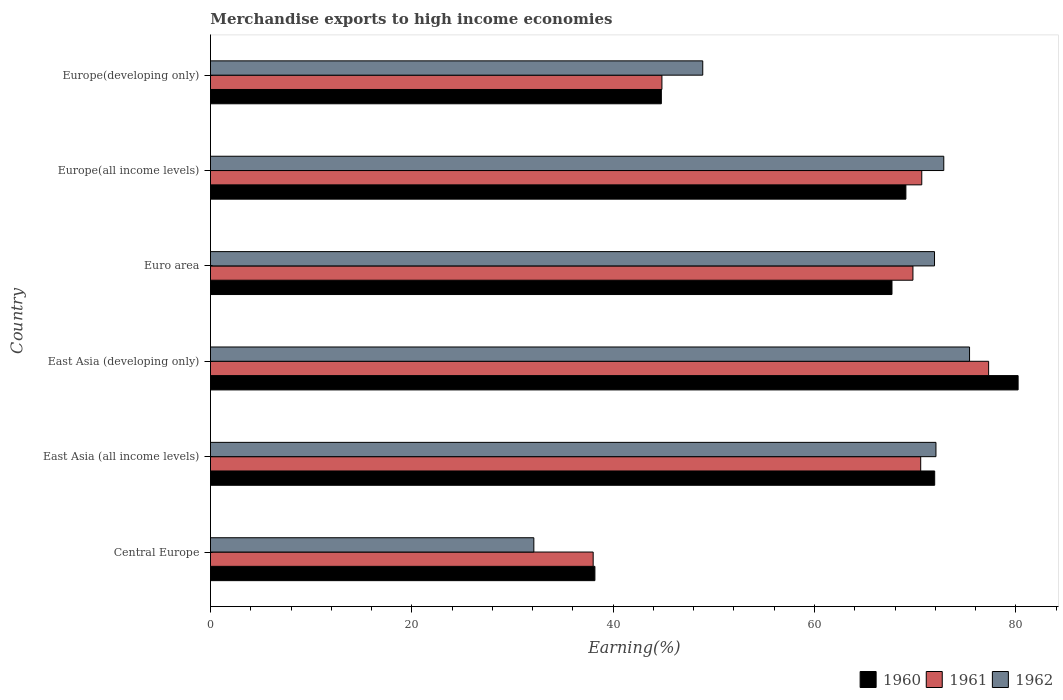How many groups of bars are there?
Offer a very short reply. 6. Are the number of bars per tick equal to the number of legend labels?
Your response must be concise. Yes. How many bars are there on the 4th tick from the bottom?
Your answer should be compact. 3. What is the label of the 1st group of bars from the top?
Provide a succinct answer. Europe(developing only). What is the percentage of amount earned from merchandise exports in 1961 in Euro area?
Provide a succinct answer. 69.78. Across all countries, what is the maximum percentage of amount earned from merchandise exports in 1962?
Ensure brevity in your answer.  75.4. Across all countries, what is the minimum percentage of amount earned from merchandise exports in 1960?
Offer a terse response. 38.19. In which country was the percentage of amount earned from merchandise exports in 1961 maximum?
Ensure brevity in your answer.  East Asia (developing only). In which country was the percentage of amount earned from merchandise exports in 1962 minimum?
Give a very brief answer. Central Europe. What is the total percentage of amount earned from merchandise exports in 1961 in the graph?
Your answer should be compact. 371.15. What is the difference between the percentage of amount earned from merchandise exports in 1962 in Central Europe and that in Euro area?
Provide a succinct answer. -39.8. What is the difference between the percentage of amount earned from merchandise exports in 1962 in Europe(all income levels) and the percentage of amount earned from merchandise exports in 1961 in East Asia (developing only)?
Provide a succinct answer. -4.45. What is the average percentage of amount earned from merchandise exports in 1962 per country?
Ensure brevity in your answer.  62.21. What is the difference between the percentage of amount earned from merchandise exports in 1962 and percentage of amount earned from merchandise exports in 1961 in Euro area?
Offer a terse response. 2.14. In how many countries, is the percentage of amount earned from merchandise exports in 1961 greater than 4 %?
Keep it short and to the point. 6. What is the ratio of the percentage of amount earned from merchandise exports in 1962 in East Asia (developing only) to that in Euro area?
Offer a very short reply. 1.05. What is the difference between the highest and the second highest percentage of amount earned from merchandise exports in 1961?
Your response must be concise. 6.64. What is the difference between the highest and the lowest percentage of amount earned from merchandise exports in 1961?
Provide a succinct answer. 39.28. In how many countries, is the percentage of amount earned from merchandise exports in 1960 greater than the average percentage of amount earned from merchandise exports in 1960 taken over all countries?
Give a very brief answer. 4. Is the sum of the percentage of amount earned from merchandise exports in 1960 in Europe(all income levels) and Europe(developing only) greater than the maximum percentage of amount earned from merchandise exports in 1962 across all countries?
Your answer should be compact. Yes. What does the 3rd bar from the top in East Asia (all income levels) represents?
Your response must be concise. 1960. What does the 2nd bar from the bottom in East Asia (all income levels) represents?
Your answer should be very brief. 1961. Are all the bars in the graph horizontal?
Your response must be concise. Yes. How many countries are there in the graph?
Your answer should be compact. 6. What is the difference between two consecutive major ticks on the X-axis?
Your answer should be very brief. 20. Are the values on the major ticks of X-axis written in scientific E-notation?
Ensure brevity in your answer.  No. How are the legend labels stacked?
Offer a terse response. Horizontal. What is the title of the graph?
Give a very brief answer. Merchandise exports to high income economies. What is the label or title of the X-axis?
Provide a short and direct response. Earning(%). What is the Earning(%) in 1960 in Central Europe?
Your answer should be compact. 38.19. What is the Earning(%) of 1961 in Central Europe?
Offer a terse response. 38.02. What is the Earning(%) in 1962 in Central Europe?
Your response must be concise. 32.12. What is the Earning(%) of 1960 in East Asia (all income levels)?
Offer a very short reply. 71.94. What is the Earning(%) in 1961 in East Asia (all income levels)?
Give a very brief answer. 70.55. What is the Earning(%) of 1962 in East Asia (all income levels)?
Offer a terse response. 72.07. What is the Earning(%) in 1960 in East Asia (developing only)?
Your answer should be very brief. 80.23. What is the Earning(%) in 1961 in East Asia (developing only)?
Offer a very short reply. 77.3. What is the Earning(%) in 1962 in East Asia (developing only)?
Your response must be concise. 75.4. What is the Earning(%) in 1960 in Euro area?
Provide a short and direct response. 67.7. What is the Earning(%) in 1961 in Euro area?
Your answer should be very brief. 69.78. What is the Earning(%) of 1962 in Euro area?
Your response must be concise. 71.92. What is the Earning(%) of 1960 in Europe(all income levels)?
Your answer should be compact. 69.08. What is the Earning(%) in 1961 in Europe(all income levels)?
Your answer should be very brief. 70.66. What is the Earning(%) in 1962 in Europe(all income levels)?
Your answer should be very brief. 72.84. What is the Earning(%) of 1960 in Europe(developing only)?
Provide a succinct answer. 44.79. What is the Earning(%) in 1961 in Europe(developing only)?
Make the answer very short. 44.84. What is the Earning(%) of 1962 in Europe(developing only)?
Keep it short and to the point. 48.9. Across all countries, what is the maximum Earning(%) of 1960?
Keep it short and to the point. 80.23. Across all countries, what is the maximum Earning(%) in 1961?
Offer a terse response. 77.3. Across all countries, what is the maximum Earning(%) of 1962?
Give a very brief answer. 75.4. Across all countries, what is the minimum Earning(%) in 1960?
Provide a short and direct response. 38.19. Across all countries, what is the minimum Earning(%) in 1961?
Your answer should be very brief. 38.02. Across all countries, what is the minimum Earning(%) of 1962?
Provide a short and direct response. 32.12. What is the total Earning(%) of 1960 in the graph?
Ensure brevity in your answer.  371.92. What is the total Earning(%) of 1961 in the graph?
Provide a succinct answer. 371.15. What is the total Earning(%) in 1962 in the graph?
Offer a terse response. 373.26. What is the difference between the Earning(%) of 1960 in Central Europe and that in East Asia (all income levels)?
Provide a short and direct response. -33.75. What is the difference between the Earning(%) of 1961 in Central Europe and that in East Asia (all income levels)?
Provide a succinct answer. -32.54. What is the difference between the Earning(%) of 1962 in Central Europe and that in East Asia (all income levels)?
Your answer should be very brief. -39.94. What is the difference between the Earning(%) of 1960 in Central Europe and that in East Asia (developing only)?
Make the answer very short. -42.04. What is the difference between the Earning(%) of 1961 in Central Europe and that in East Asia (developing only)?
Ensure brevity in your answer.  -39.28. What is the difference between the Earning(%) in 1962 in Central Europe and that in East Asia (developing only)?
Provide a short and direct response. -43.28. What is the difference between the Earning(%) of 1960 in Central Europe and that in Euro area?
Your response must be concise. -29.51. What is the difference between the Earning(%) of 1961 in Central Europe and that in Euro area?
Ensure brevity in your answer.  -31.76. What is the difference between the Earning(%) of 1962 in Central Europe and that in Euro area?
Ensure brevity in your answer.  -39.8. What is the difference between the Earning(%) in 1960 in Central Europe and that in Europe(all income levels)?
Ensure brevity in your answer.  -30.89. What is the difference between the Earning(%) of 1961 in Central Europe and that in Europe(all income levels)?
Provide a short and direct response. -32.64. What is the difference between the Earning(%) in 1962 in Central Europe and that in Europe(all income levels)?
Your answer should be very brief. -40.72. What is the difference between the Earning(%) of 1960 in Central Europe and that in Europe(developing only)?
Offer a very short reply. -6.6. What is the difference between the Earning(%) in 1961 in Central Europe and that in Europe(developing only)?
Your answer should be compact. -6.83. What is the difference between the Earning(%) in 1962 in Central Europe and that in Europe(developing only)?
Ensure brevity in your answer.  -16.78. What is the difference between the Earning(%) of 1960 in East Asia (all income levels) and that in East Asia (developing only)?
Make the answer very short. -8.29. What is the difference between the Earning(%) of 1961 in East Asia (all income levels) and that in East Asia (developing only)?
Provide a succinct answer. -6.75. What is the difference between the Earning(%) in 1962 in East Asia (all income levels) and that in East Asia (developing only)?
Give a very brief answer. -3.34. What is the difference between the Earning(%) of 1960 in East Asia (all income levels) and that in Euro area?
Keep it short and to the point. 4.24. What is the difference between the Earning(%) of 1961 in East Asia (all income levels) and that in Euro area?
Keep it short and to the point. 0.77. What is the difference between the Earning(%) of 1962 in East Asia (all income levels) and that in Euro area?
Offer a terse response. 0.14. What is the difference between the Earning(%) in 1960 in East Asia (all income levels) and that in Europe(all income levels)?
Give a very brief answer. 2.86. What is the difference between the Earning(%) of 1961 in East Asia (all income levels) and that in Europe(all income levels)?
Make the answer very short. -0.1. What is the difference between the Earning(%) of 1962 in East Asia (all income levels) and that in Europe(all income levels)?
Ensure brevity in your answer.  -0.78. What is the difference between the Earning(%) of 1960 in East Asia (all income levels) and that in Europe(developing only)?
Your response must be concise. 27.15. What is the difference between the Earning(%) in 1961 in East Asia (all income levels) and that in Europe(developing only)?
Your answer should be very brief. 25.71. What is the difference between the Earning(%) of 1962 in East Asia (all income levels) and that in Europe(developing only)?
Your answer should be compact. 23.17. What is the difference between the Earning(%) of 1960 in East Asia (developing only) and that in Euro area?
Make the answer very short. 12.53. What is the difference between the Earning(%) in 1961 in East Asia (developing only) and that in Euro area?
Give a very brief answer. 7.52. What is the difference between the Earning(%) in 1962 in East Asia (developing only) and that in Euro area?
Your answer should be very brief. 3.48. What is the difference between the Earning(%) in 1960 in East Asia (developing only) and that in Europe(all income levels)?
Keep it short and to the point. 11.15. What is the difference between the Earning(%) of 1961 in East Asia (developing only) and that in Europe(all income levels)?
Give a very brief answer. 6.64. What is the difference between the Earning(%) in 1962 in East Asia (developing only) and that in Europe(all income levels)?
Provide a succinct answer. 2.56. What is the difference between the Earning(%) of 1960 in East Asia (developing only) and that in Europe(developing only)?
Provide a short and direct response. 35.44. What is the difference between the Earning(%) in 1961 in East Asia (developing only) and that in Europe(developing only)?
Provide a succinct answer. 32.45. What is the difference between the Earning(%) in 1962 in East Asia (developing only) and that in Europe(developing only)?
Your answer should be compact. 26.5. What is the difference between the Earning(%) in 1960 in Euro area and that in Europe(all income levels)?
Ensure brevity in your answer.  -1.38. What is the difference between the Earning(%) in 1961 in Euro area and that in Europe(all income levels)?
Your answer should be compact. -0.88. What is the difference between the Earning(%) of 1962 in Euro area and that in Europe(all income levels)?
Provide a succinct answer. -0.92. What is the difference between the Earning(%) in 1960 in Euro area and that in Europe(developing only)?
Your answer should be compact. 22.91. What is the difference between the Earning(%) in 1961 in Euro area and that in Europe(developing only)?
Your answer should be very brief. 24.93. What is the difference between the Earning(%) in 1962 in Euro area and that in Europe(developing only)?
Your answer should be compact. 23.02. What is the difference between the Earning(%) of 1960 in Europe(all income levels) and that in Europe(developing only)?
Give a very brief answer. 24.29. What is the difference between the Earning(%) of 1961 in Europe(all income levels) and that in Europe(developing only)?
Your response must be concise. 25.81. What is the difference between the Earning(%) in 1962 in Europe(all income levels) and that in Europe(developing only)?
Your response must be concise. 23.94. What is the difference between the Earning(%) of 1960 in Central Europe and the Earning(%) of 1961 in East Asia (all income levels)?
Provide a short and direct response. -32.36. What is the difference between the Earning(%) of 1960 in Central Europe and the Earning(%) of 1962 in East Asia (all income levels)?
Give a very brief answer. -33.88. What is the difference between the Earning(%) in 1961 in Central Europe and the Earning(%) in 1962 in East Asia (all income levels)?
Provide a short and direct response. -34.05. What is the difference between the Earning(%) in 1960 in Central Europe and the Earning(%) in 1961 in East Asia (developing only)?
Offer a very short reply. -39.11. What is the difference between the Earning(%) in 1960 in Central Europe and the Earning(%) in 1962 in East Asia (developing only)?
Provide a short and direct response. -37.22. What is the difference between the Earning(%) of 1961 in Central Europe and the Earning(%) of 1962 in East Asia (developing only)?
Offer a terse response. -37.39. What is the difference between the Earning(%) of 1960 in Central Europe and the Earning(%) of 1961 in Euro area?
Your answer should be compact. -31.59. What is the difference between the Earning(%) of 1960 in Central Europe and the Earning(%) of 1962 in Euro area?
Give a very brief answer. -33.74. What is the difference between the Earning(%) in 1961 in Central Europe and the Earning(%) in 1962 in Euro area?
Provide a succinct answer. -33.91. What is the difference between the Earning(%) in 1960 in Central Europe and the Earning(%) in 1961 in Europe(all income levels)?
Provide a succinct answer. -32.47. What is the difference between the Earning(%) in 1960 in Central Europe and the Earning(%) in 1962 in Europe(all income levels)?
Ensure brevity in your answer.  -34.66. What is the difference between the Earning(%) of 1961 in Central Europe and the Earning(%) of 1962 in Europe(all income levels)?
Give a very brief answer. -34.83. What is the difference between the Earning(%) of 1960 in Central Europe and the Earning(%) of 1961 in Europe(developing only)?
Keep it short and to the point. -6.66. What is the difference between the Earning(%) of 1960 in Central Europe and the Earning(%) of 1962 in Europe(developing only)?
Offer a very short reply. -10.71. What is the difference between the Earning(%) of 1961 in Central Europe and the Earning(%) of 1962 in Europe(developing only)?
Offer a very short reply. -10.88. What is the difference between the Earning(%) of 1960 in East Asia (all income levels) and the Earning(%) of 1961 in East Asia (developing only)?
Offer a terse response. -5.36. What is the difference between the Earning(%) in 1960 in East Asia (all income levels) and the Earning(%) in 1962 in East Asia (developing only)?
Keep it short and to the point. -3.46. What is the difference between the Earning(%) in 1961 in East Asia (all income levels) and the Earning(%) in 1962 in East Asia (developing only)?
Your answer should be compact. -4.85. What is the difference between the Earning(%) in 1960 in East Asia (all income levels) and the Earning(%) in 1961 in Euro area?
Make the answer very short. 2.16. What is the difference between the Earning(%) of 1960 in East Asia (all income levels) and the Earning(%) of 1962 in Euro area?
Keep it short and to the point. 0.02. What is the difference between the Earning(%) of 1961 in East Asia (all income levels) and the Earning(%) of 1962 in Euro area?
Your answer should be very brief. -1.37. What is the difference between the Earning(%) in 1960 in East Asia (all income levels) and the Earning(%) in 1961 in Europe(all income levels)?
Your answer should be compact. 1.28. What is the difference between the Earning(%) of 1960 in East Asia (all income levels) and the Earning(%) of 1962 in Europe(all income levels)?
Your answer should be compact. -0.9. What is the difference between the Earning(%) of 1961 in East Asia (all income levels) and the Earning(%) of 1962 in Europe(all income levels)?
Give a very brief answer. -2.29. What is the difference between the Earning(%) in 1960 in East Asia (all income levels) and the Earning(%) in 1961 in Europe(developing only)?
Offer a very short reply. 27.1. What is the difference between the Earning(%) of 1960 in East Asia (all income levels) and the Earning(%) of 1962 in Europe(developing only)?
Make the answer very short. 23.04. What is the difference between the Earning(%) of 1961 in East Asia (all income levels) and the Earning(%) of 1962 in Europe(developing only)?
Give a very brief answer. 21.65. What is the difference between the Earning(%) of 1960 in East Asia (developing only) and the Earning(%) of 1961 in Euro area?
Provide a short and direct response. 10.45. What is the difference between the Earning(%) of 1960 in East Asia (developing only) and the Earning(%) of 1962 in Euro area?
Your answer should be very brief. 8.3. What is the difference between the Earning(%) of 1961 in East Asia (developing only) and the Earning(%) of 1962 in Euro area?
Your answer should be compact. 5.37. What is the difference between the Earning(%) of 1960 in East Asia (developing only) and the Earning(%) of 1961 in Europe(all income levels)?
Make the answer very short. 9.57. What is the difference between the Earning(%) in 1960 in East Asia (developing only) and the Earning(%) in 1962 in Europe(all income levels)?
Your response must be concise. 7.38. What is the difference between the Earning(%) in 1961 in East Asia (developing only) and the Earning(%) in 1962 in Europe(all income levels)?
Offer a very short reply. 4.45. What is the difference between the Earning(%) in 1960 in East Asia (developing only) and the Earning(%) in 1961 in Europe(developing only)?
Make the answer very short. 35.38. What is the difference between the Earning(%) in 1960 in East Asia (developing only) and the Earning(%) in 1962 in Europe(developing only)?
Your answer should be very brief. 31.33. What is the difference between the Earning(%) of 1961 in East Asia (developing only) and the Earning(%) of 1962 in Europe(developing only)?
Make the answer very short. 28.4. What is the difference between the Earning(%) in 1960 in Euro area and the Earning(%) in 1961 in Europe(all income levels)?
Make the answer very short. -2.96. What is the difference between the Earning(%) of 1960 in Euro area and the Earning(%) of 1962 in Europe(all income levels)?
Provide a succinct answer. -5.15. What is the difference between the Earning(%) of 1961 in Euro area and the Earning(%) of 1962 in Europe(all income levels)?
Give a very brief answer. -3.06. What is the difference between the Earning(%) of 1960 in Euro area and the Earning(%) of 1961 in Europe(developing only)?
Ensure brevity in your answer.  22.85. What is the difference between the Earning(%) of 1960 in Euro area and the Earning(%) of 1962 in Europe(developing only)?
Provide a succinct answer. 18.8. What is the difference between the Earning(%) of 1961 in Euro area and the Earning(%) of 1962 in Europe(developing only)?
Offer a very short reply. 20.88. What is the difference between the Earning(%) in 1960 in Europe(all income levels) and the Earning(%) in 1961 in Europe(developing only)?
Keep it short and to the point. 24.24. What is the difference between the Earning(%) of 1960 in Europe(all income levels) and the Earning(%) of 1962 in Europe(developing only)?
Give a very brief answer. 20.18. What is the difference between the Earning(%) of 1961 in Europe(all income levels) and the Earning(%) of 1962 in Europe(developing only)?
Provide a succinct answer. 21.76. What is the average Earning(%) of 1960 per country?
Give a very brief answer. 61.99. What is the average Earning(%) in 1961 per country?
Your answer should be compact. 61.86. What is the average Earning(%) of 1962 per country?
Provide a succinct answer. 62.21. What is the difference between the Earning(%) of 1960 and Earning(%) of 1961 in Central Europe?
Offer a very short reply. 0.17. What is the difference between the Earning(%) of 1960 and Earning(%) of 1962 in Central Europe?
Offer a terse response. 6.07. What is the difference between the Earning(%) of 1961 and Earning(%) of 1962 in Central Europe?
Provide a short and direct response. 5.89. What is the difference between the Earning(%) of 1960 and Earning(%) of 1961 in East Asia (all income levels)?
Provide a succinct answer. 1.39. What is the difference between the Earning(%) in 1960 and Earning(%) in 1962 in East Asia (all income levels)?
Ensure brevity in your answer.  -0.13. What is the difference between the Earning(%) of 1961 and Earning(%) of 1962 in East Asia (all income levels)?
Your answer should be compact. -1.51. What is the difference between the Earning(%) in 1960 and Earning(%) in 1961 in East Asia (developing only)?
Your answer should be very brief. 2.93. What is the difference between the Earning(%) of 1960 and Earning(%) of 1962 in East Asia (developing only)?
Offer a terse response. 4.82. What is the difference between the Earning(%) of 1961 and Earning(%) of 1962 in East Asia (developing only)?
Offer a terse response. 1.89. What is the difference between the Earning(%) of 1960 and Earning(%) of 1961 in Euro area?
Provide a succinct answer. -2.08. What is the difference between the Earning(%) of 1960 and Earning(%) of 1962 in Euro area?
Your answer should be very brief. -4.23. What is the difference between the Earning(%) of 1961 and Earning(%) of 1962 in Euro area?
Offer a very short reply. -2.14. What is the difference between the Earning(%) of 1960 and Earning(%) of 1961 in Europe(all income levels)?
Keep it short and to the point. -1.58. What is the difference between the Earning(%) of 1960 and Earning(%) of 1962 in Europe(all income levels)?
Your answer should be compact. -3.76. What is the difference between the Earning(%) in 1961 and Earning(%) in 1962 in Europe(all income levels)?
Keep it short and to the point. -2.19. What is the difference between the Earning(%) in 1960 and Earning(%) in 1961 in Europe(developing only)?
Keep it short and to the point. -0.06. What is the difference between the Earning(%) in 1960 and Earning(%) in 1962 in Europe(developing only)?
Keep it short and to the point. -4.11. What is the difference between the Earning(%) in 1961 and Earning(%) in 1962 in Europe(developing only)?
Your response must be concise. -4.06. What is the ratio of the Earning(%) in 1960 in Central Europe to that in East Asia (all income levels)?
Give a very brief answer. 0.53. What is the ratio of the Earning(%) in 1961 in Central Europe to that in East Asia (all income levels)?
Your response must be concise. 0.54. What is the ratio of the Earning(%) in 1962 in Central Europe to that in East Asia (all income levels)?
Keep it short and to the point. 0.45. What is the ratio of the Earning(%) in 1960 in Central Europe to that in East Asia (developing only)?
Offer a very short reply. 0.48. What is the ratio of the Earning(%) in 1961 in Central Europe to that in East Asia (developing only)?
Offer a terse response. 0.49. What is the ratio of the Earning(%) of 1962 in Central Europe to that in East Asia (developing only)?
Keep it short and to the point. 0.43. What is the ratio of the Earning(%) in 1960 in Central Europe to that in Euro area?
Your response must be concise. 0.56. What is the ratio of the Earning(%) in 1961 in Central Europe to that in Euro area?
Offer a terse response. 0.54. What is the ratio of the Earning(%) of 1962 in Central Europe to that in Euro area?
Your answer should be compact. 0.45. What is the ratio of the Earning(%) of 1960 in Central Europe to that in Europe(all income levels)?
Ensure brevity in your answer.  0.55. What is the ratio of the Earning(%) of 1961 in Central Europe to that in Europe(all income levels)?
Offer a very short reply. 0.54. What is the ratio of the Earning(%) in 1962 in Central Europe to that in Europe(all income levels)?
Ensure brevity in your answer.  0.44. What is the ratio of the Earning(%) of 1960 in Central Europe to that in Europe(developing only)?
Ensure brevity in your answer.  0.85. What is the ratio of the Earning(%) in 1961 in Central Europe to that in Europe(developing only)?
Keep it short and to the point. 0.85. What is the ratio of the Earning(%) of 1962 in Central Europe to that in Europe(developing only)?
Your answer should be compact. 0.66. What is the ratio of the Earning(%) of 1960 in East Asia (all income levels) to that in East Asia (developing only)?
Make the answer very short. 0.9. What is the ratio of the Earning(%) of 1961 in East Asia (all income levels) to that in East Asia (developing only)?
Give a very brief answer. 0.91. What is the ratio of the Earning(%) in 1962 in East Asia (all income levels) to that in East Asia (developing only)?
Give a very brief answer. 0.96. What is the ratio of the Earning(%) of 1960 in East Asia (all income levels) to that in Euro area?
Provide a short and direct response. 1.06. What is the ratio of the Earning(%) in 1961 in East Asia (all income levels) to that in Euro area?
Your answer should be very brief. 1.01. What is the ratio of the Earning(%) in 1962 in East Asia (all income levels) to that in Euro area?
Offer a very short reply. 1. What is the ratio of the Earning(%) in 1960 in East Asia (all income levels) to that in Europe(all income levels)?
Make the answer very short. 1.04. What is the ratio of the Earning(%) in 1962 in East Asia (all income levels) to that in Europe(all income levels)?
Offer a terse response. 0.99. What is the ratio of the Earning(%) in 1960 in East Asia (all income levels) to that in Europe(developing only)?
Make the answer very short. 1.61. What is the ratio of the Earning(%) of 1961 in East Asia (all income levels) to that in Europe(developing only)?
Your answer should be compact. 1.57. What is the ratio of the Earning(%) in 1962 in East Asia (all income levels) to that in Europe(developing only)?
Ensure brevity in your answer.  1.47. What is the ratio of the Earning(%) in 1960 in East Asia (developing only) to that in Euro area?
Your answer should be very brief. 1.19. What is the ratio of the Earning(%) of 1961 in East Asia (developing only) to that in Euro area?
Ensure brevity in your answer.  1.11. What is the ratio of the Earning(%) of 1962 in East Asia (developing only) to that in Euro area?
Offer a terse response. 1.05. What is the ratio of the Earning(%) in 1960 in East Asia (developing only) to that in Europe(all income levels)?
Your answer should be very brief. 1.16. What is the ratio of the Earning(%) in 1961 in East Asia (developing only) to that in Europe(all income levels)?
Make the answer very short. 1.09. What is the ratio of the Earning(%) in 1962 in East Asia (developing only) to that in Europe(all income levels)?
Ensure brevity in your answer.  1.04. What is the ratio of the Earning(%) of 1960 in East Asia (developing only) to that in Europe(developing only)?
Provide a succinct answer. 1.79. What is the ratio of the Earning(%) of 1961 in East Asia (developing only) to that in Europe(developing only)?
Provide a short and direct response. 1.72. What is the ratio of the Earning(%) of 1962 in East Asia (developing only) to that in Europe(developing only)?
Give a very brief answer. 1.54. What is the ratio of the Earning(%) of 1961 in Euro area to that in Europe(all income levels)?
Keep it short and to the point. 0.99. What is the ratio of the Earning(%) of 1962 in Euro area to that in Europe(all income levels)?
Provide a short and direct response. 0.99. What is the ratio of the Earning(%) of 1960 in Euro area to that in Europe(developing only)?
Your answer should be compact. 1.51. What is the ratio of the Earning(%) of 1961 in Euro area to that in Europe(developing only)?
Your answer should be compact. 1.56. What is the ratio of the Earning(%) of 1962 in Euro area to that in Europe(developing only)?
Ensure brevity in your answer.  1.47. What is the ratio of the Earning(%) in 1960 in Europe(all income levels) to that in Europe(developing only)?
Give a very brief answer. 1.54. What is the ratio of the Earning(%) of 1961 in Europe(all income levels) to that in Europe(developing only)?
Give a very brief answer. 1.58. What is the ratio of the Earning(%) of 1962 in Europe(all income levels) to that in Europe(developing only)?
Provide a succinct answer. 1.49. What is the difference between the highest and the second highest Earning(%) of 1960?
Ensure brevity in your answer.  8.29. What is the difference between the highest and the second highest Earning(%) of 1961?
Ensure brevity in your answer.  6.64. What is the difference between the highest and the second highest Earning(%) of 1962?
Provide a succinct answer. 2.56. What is the difference between the highest and the lowest Earning(%) in 1960?
Provide a succinct answer. 42.04. What is the difference between the highest and the lowest Earning(%) of 1961?
Make the answer very short. 39.28. What is the difference between the highest and the lowest Earning(%) in 1962?
Your response must be concise. 43.28. 